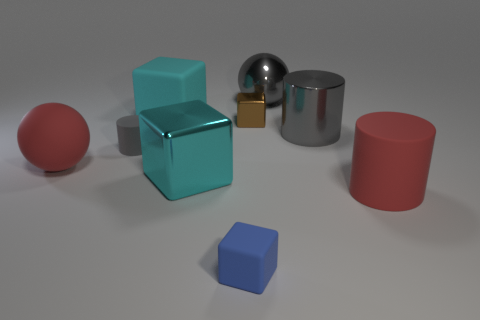There is a cube that is right of the blue object; does it have the same color as the big rubber cylinder?
Offer a very short reply. No. How many blocks are large red objects or big cyan rubber things?
Keep it short and to the point. 1. There is a ball that is to the left of the small block that is in front of the red object on the left side of the gray metallic cylinder; how big is it?
Your response must be concise. Large. What shape is the blue matte thing that is the same size as the brown shiny block?
Your answer should be very brief. Cube. The brown shiny thing is what shape?
Provide a succinct answer. Cube. Is the material of the gray cylinder that is left of the large gray ball the same as the brown object?
Give a very brief answer. No. How big is the red matte thing that is behind the large red matte thing that is on the right side of the blue thing?
Your answer should be compact. Large. What is the color of the big metallic object that is both in front of the small brown metallic block and to the right of the tiny brown shiny block?
Give a very brief answer. Gray. There is a red cylinder that is the same size as the metal sphere; what is its material?
Offer a terse response. Rubber. How many other objects are the same material as the brown object?
Provide a short and direct response. 3. 